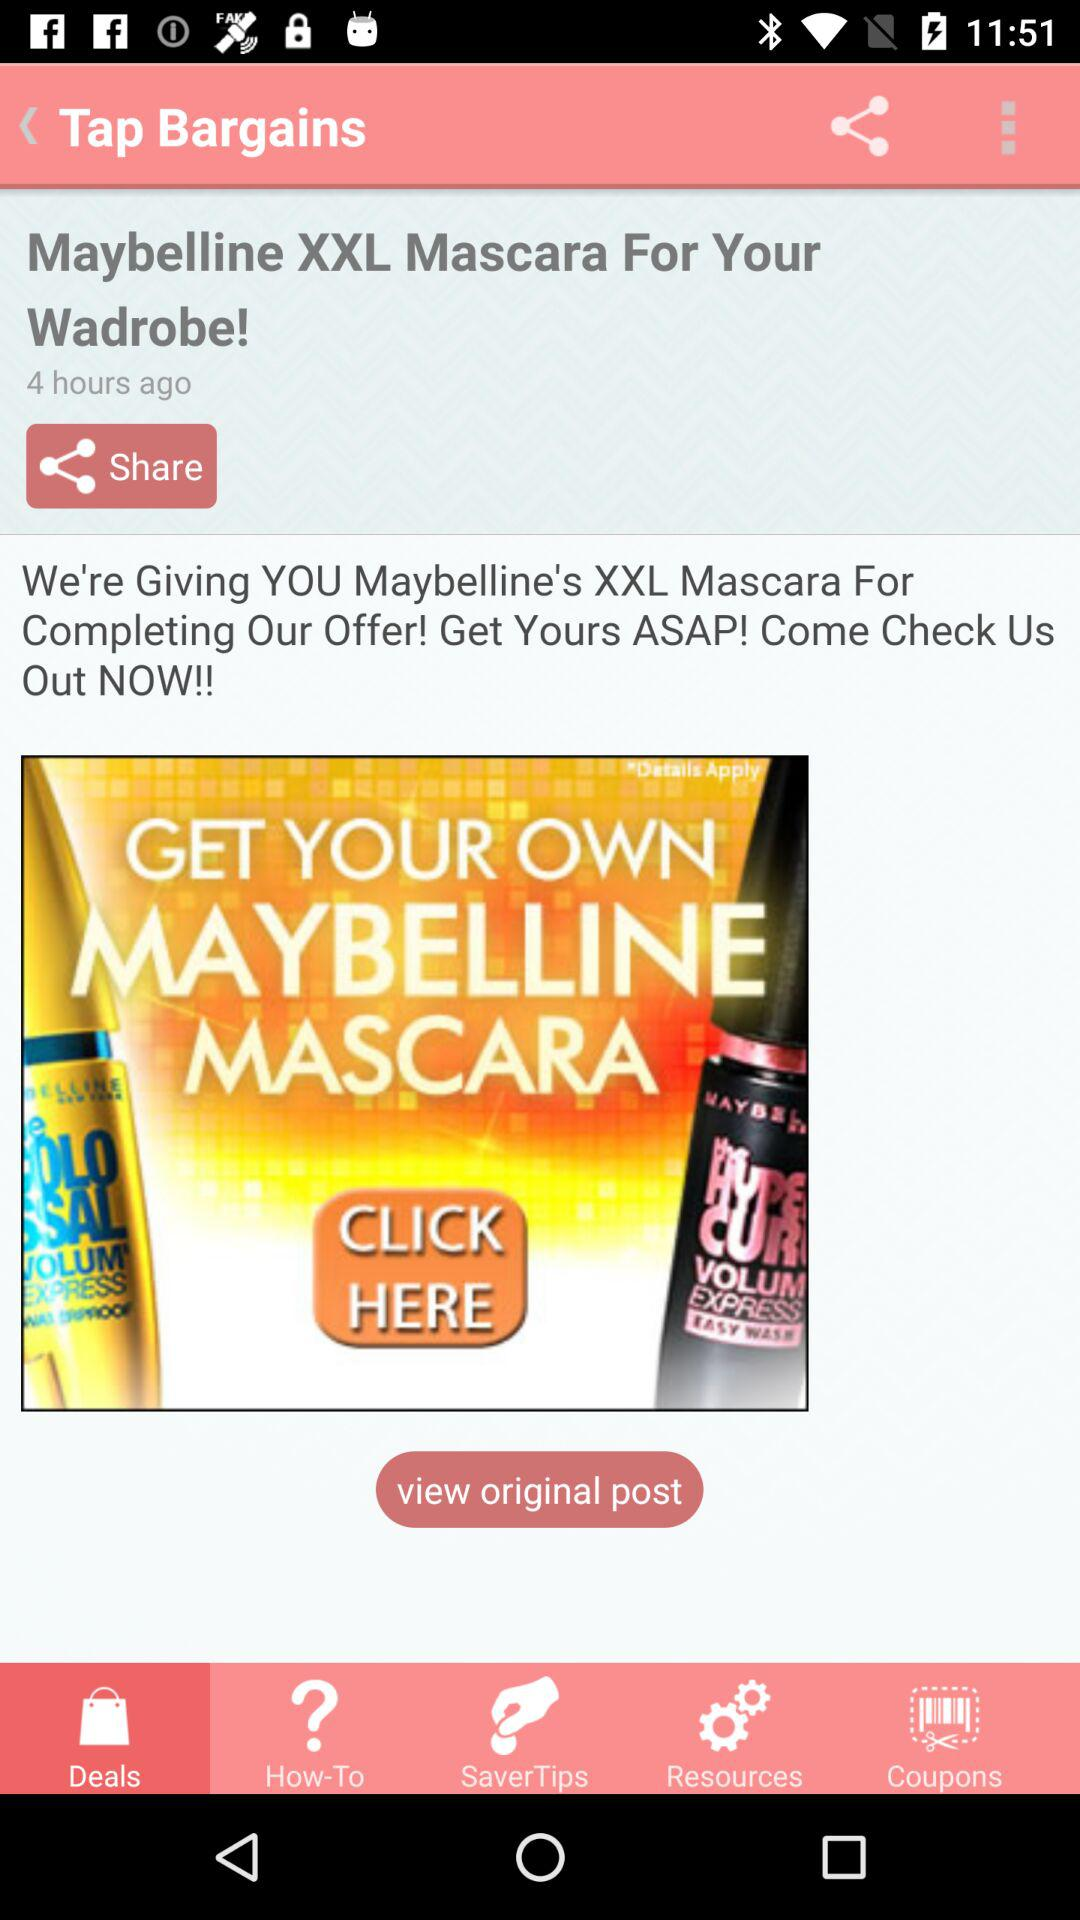What tab is selected? The selected tab is "Deals". 